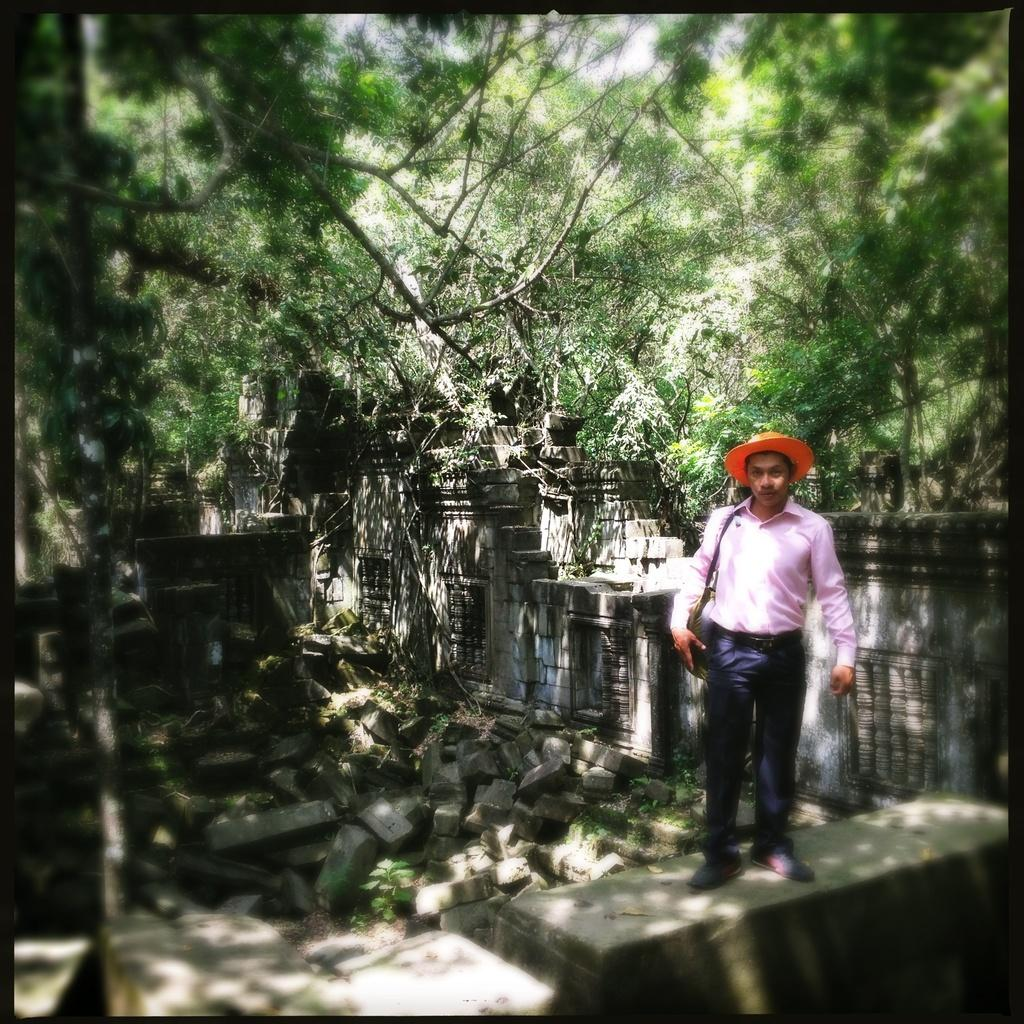What is the man in the image doing? The man is standing on a platform. What is the man carrying in the image? The man is carrying a bag on his shoulder. What is the man wearing on his head? The man is wearing a hat on his head. What can be seen in the background of the image? There are stones, a wall, and trees in the background of the image. What type of wrench is the doctor using to fix the unit in the image? There is no wrench, doctor, or unit present in the image. 